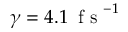Convert formula to latex. <formula><loc_0><loc_0><loc_500><loc_500>\gamma = 4 . 1 \, f s ^ { - 1 }</formula> 